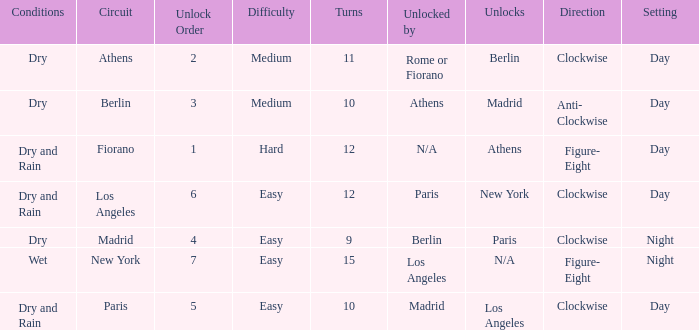How many instances is the unlocked n/a? 1.0. 